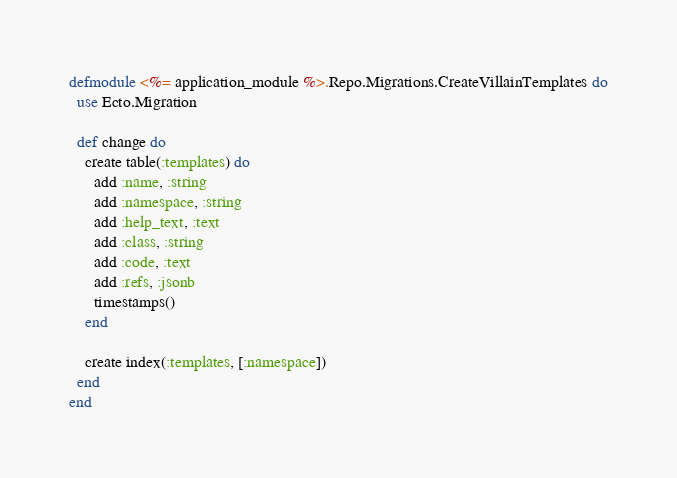Convert code to text. <code><loc_0><loc_0><loc_500><loc_500><_Elixir_>defmodule <%= application_module %>.Repo.Migrations.CreateVillainTemplates do
  use Ecto.Migration

  def change do
    create table(:templates) do
      add :name, :string
      add :namespace, :string
      add :help_text, :text
      add :class, :string
      add :code, :text
      add :refs, :jsonb
      timestamps()
    end

    create index(:templates, [:namespace])
  end
end
</code> 